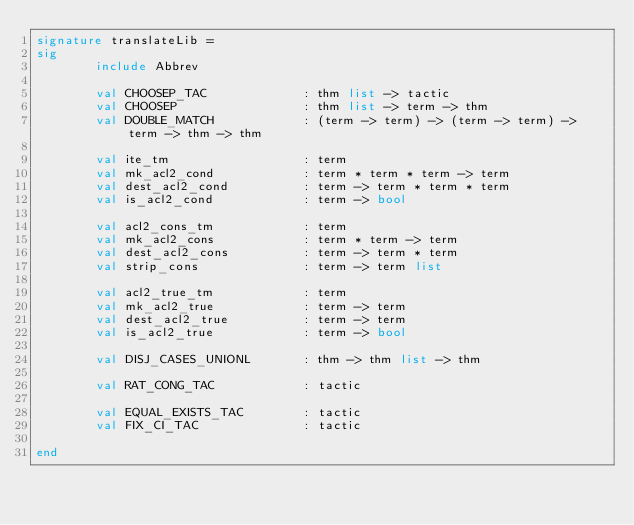<code> <loc_0><loc_0><loc_500><loc_500><_SML_>signature translateLib =
sig
        include Abbrev

        val CHOOSEP_TAC             : thm list -> tactic
        val CHOOSEP                 : thm list -> term -> thm
        val DOUBLE_MATCH            : (term -> term) -> (term -> term) -> term -> thm -> thm

        val ite_tm                  : term
        val mk_acl2_cond            : term * term * term -> term
        val dest_acl2_cond          : term -> term * term * term
        val is_acl2_cond            : term -> bool

        val acl2_cons_tm            : term
        val mk_acl2_cons            : term * term -> term
        val dest_acl2_cons          : term -> term * term
        val strip_cons              : term -> term list

        val acl2_true_tm            : term
        val mk_acl2_true            : term -> term
        val dest_acl2_true          : term -> term
        val is_acl2_true            : term -> bool

        val DISJ_CASES_UNIONL       : thm -> thm list -> thm

        val RAT_CONG_TAC            : tactic

        val EQUAL_EXISTS_TAC        : tactic
        val FIX_CI_TAC              : tactic

end
</code> 